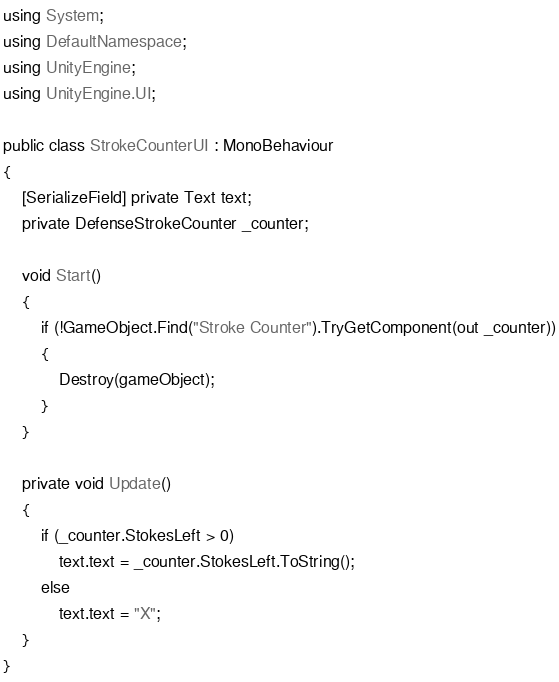Convert code to text. <code><loc_0><loc_0><loc_500><loc_500><_C#_>using System;
using DefaultNamespace;
using UnityEngine;
using UnityEngine.UI;

public class StrokeCounterUI : MonoBehaviour
{
    [SerializeField] private Text text;
    private DefenseStrokeCounter _counter;

    void Start()
    {
        if (!GameObject.Find("Stroke Counter").TryGetComponent(out _counter))
        {
            Destroy(gameObject);
        }
    }

    private void Update()
    {
        if (_counter.StokesLeft > 0)
            text.text = _counter.StokesLeft.ToString();
        else
            text.text = "X";
    }
}</code> 